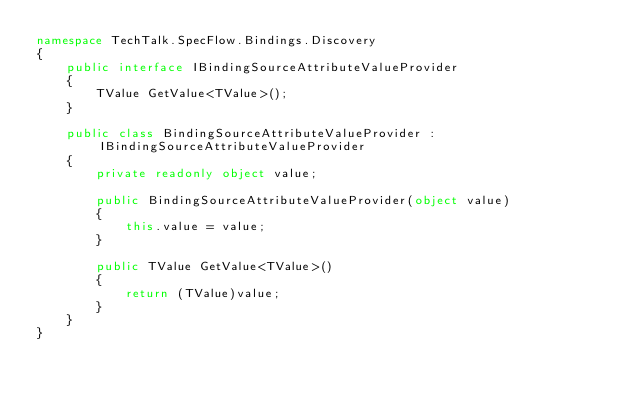<code> <loc_0><loc_0><loc_500><loc_500><_C#_>namespace TechTalk.SpecFlow.Bindings.Discovery
{
    public interface IBindingSourceAttributeValueProvider
    {
        TValue GetValue<TValue>();
    }

    public class BindingSourceAttributeValueProvider : IBindingSourceAttributeValueProvider
    {
        private readonly object value;

        public BindingSourceAttributeValueProvider(object value)
        {
            this.value = value;
        }

        public TValue GetValue<TValue>()
        {
            return (TValue)value;
        }
    }
}</code> 